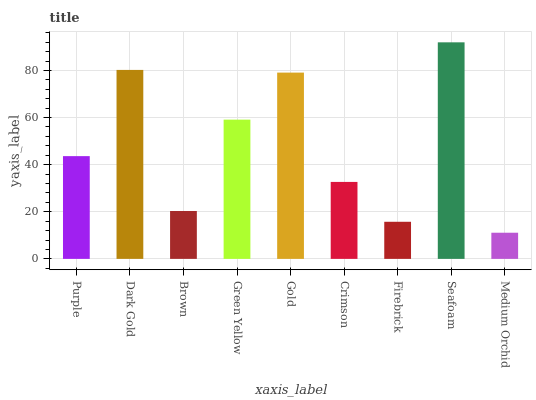Is Medium Orchid the minimum?
Answer yes or no. Yes. Is Seafoam the maximum?
Answer yes or no. Yes. Is Dark Gold the minimum?
Answer yes or no. No. Is Dark Gold the maximum?
Answer yes or no. No. Is Dark Gold greater than Purple?
Answer yes or no. Yes. Is Purple less than Dark Gold?
Answer yes or no. Yes. Is Purple greater than Dark Gold?
Answer yes or no. No. Is Dark Gold less than Purple?
Answer yes or no. No. Is Purple the high median?
Answer yes or no. Yes. Is Purple the low median?
Answer yes or no. Yes. Is Gold the high median?
Answer yes or no. No. Is Gold the low median?
Answer yes or no. No. 